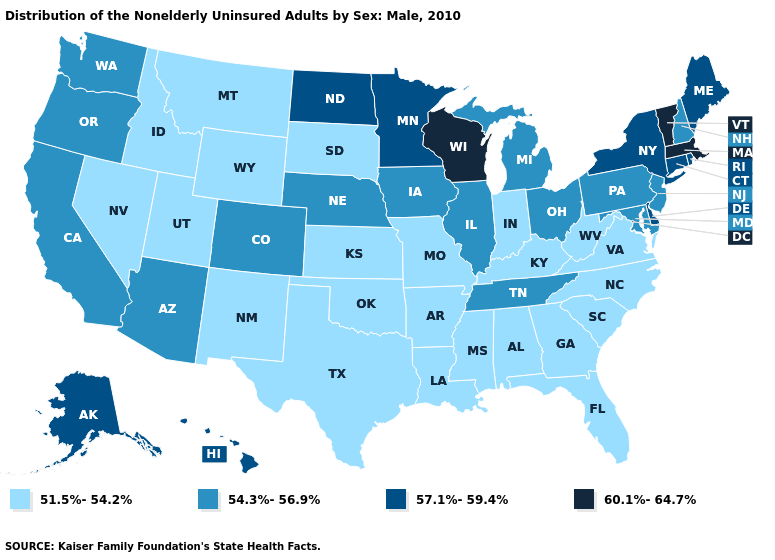Name the states that have a value in the range 51.5%-54.2%?
Short answer required. Alabama, Arkansas, Florida, Georgia, Idaho, Indiana, Kansas, Kentucky, Louisiana, Mississippi, Missouri, Montana, Nevada, New Mexico, North Carolina, Oklahoma, South Carolina, South Dakota, Texas, Utah, Virginia, West Virginia, Wyoming. Name the states that have a value in the range 57.1%-59.4%?
Answer briefly. Alaska, Connecticut, Delaware, Hawaii, Maine, Minnesota, New York, North Dakota, Rhode Island. What is the value of Alabama?
Be succinct. 51.5%-54.2%. Name the states that have a value in the range 51.5%-54.2%?
Short answer required. Alabama, Arkansas, Florida, Georgia, Idaho, Indiana, Kansas, Kentucky, Louisiana, Mississippi, Missouri, Montana, Nevada, New Mexico, North Carolina, Oklahoma, South Carolina, South Dakota, Texas, Utah, Virginia, West Virginia, Wyoming. What is the lowest value in states that border Utah?
Be succinct. 51.5%-54.2%. Name the states that have a value in the range 60.1%-64.7%?
Keep it brief. Massachusetts, Vermont, Wisconsin. Does Indiana have the lowest value in the MidWest?
Short answer required. Yes. What is the value of New York?
Short answer required. 57.1%-59.4%. What is the value of Maine?
Concise answer only. 57.1%-59.4%. What is the highest value in states that border Vermont?
Give a very brief answer. 60.1%-64.7%. What is the value of Alabama?
Short answer required. 51.5%-54.2%. Which states have the lowest value in the USA?
Write a very short answer. Alabama, Arkansas, Florida, Georgia, Idaho, Indiana, Kansas, Kentucky, Louisiana, Mississippi, Missouri, Montana, Nevada, New Mexico, North Carolina, Oklahoma, South Carolina, South Dakota, Texas, Utah, Virginia, West Virginia, Wyoming. Which states hav the highest value in the West?
Be succinct. Alaska, Hawaii. Does South Dakota have a lower value than Oregon?
Answer briefly. Yes. 